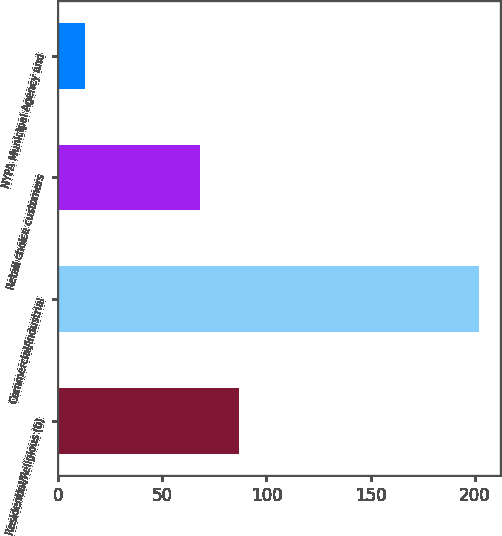<chart> <loc_0><loc_0><loc_500><loc_500><bar_chart><fcel>Residential/Religious (b)<fcel>Commercial/Industrial<fcel>Retail choice customers<fcel>NYPA Municipal Agency and<nl><fcel>86.9<fcel>202<fcel>68<fcel>13<nl></chart> 